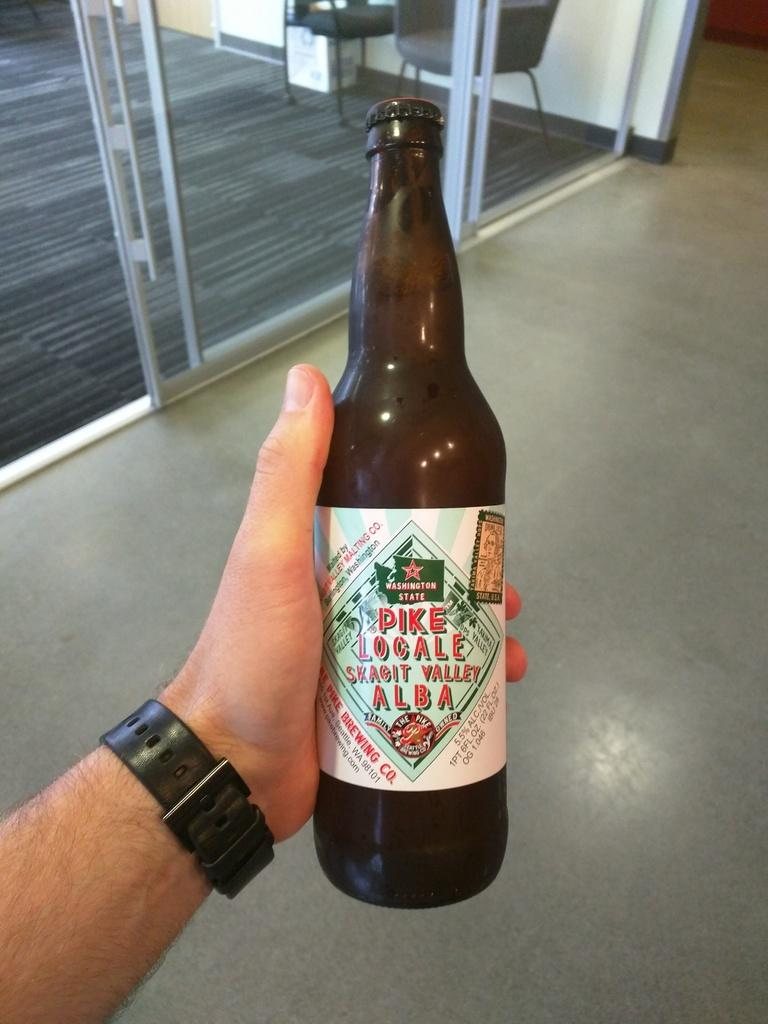<image>
Render a clear and concise summary of the photo. The man is holding a bottle of malt from Seattle's Pike Brewing Co. 